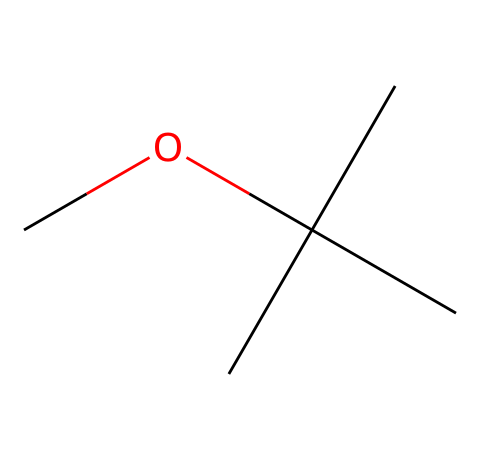What is the name of this chemical? The structure shows the functional group characteristic of ethers, and recognizing it as methyl tert-butyl ether (MTBE) is a direct observation from the arrangement of carbon and oxygen atoms in the SMILES notation.
Answer: methyl tert-butyl ether How many carbon atoms are present in this molecule? By analyzing the structure, we note there are four carbon atoms (specifically "C(C)(C)" indicates three tert-butyl groups branching off one central carbon, and the "C" before the "O" indicates one more carbon).
Answer: four What is the molecular formula of this ether? From the SMILES representation, we can count the atoms: there are 5 carbon atoms, 12 hydrogen atoms, and 1 oxygen atom, leading us to the formula C5H12O.
Answer: C5H12O What type of chemical bond connects the oxygen to the carbon atoms? In ethers, the bond between oxygen and carbon is a single covalent bond, which can be inferred from the structure as there are no double bonds shown in the chemical's SMILES representation.
Answer: single bond What functional group does methyl tert-butyl ether belong to? The ether classification is evident from the presence of the oxygen atom connected to two alkyl groups (tert-butyl and methyl), highlighting its functional group as an ether.
Answer: ether What is the significance of using methyl tert-butyl ether as a fuel additive? Methyl tert-butyl ether serves as an octane booster to improve fuel quality and performance, which can be particularly advantageous for operating telescopes in remote observatories where fuel efficiency is critical.
Answer: octane booster 